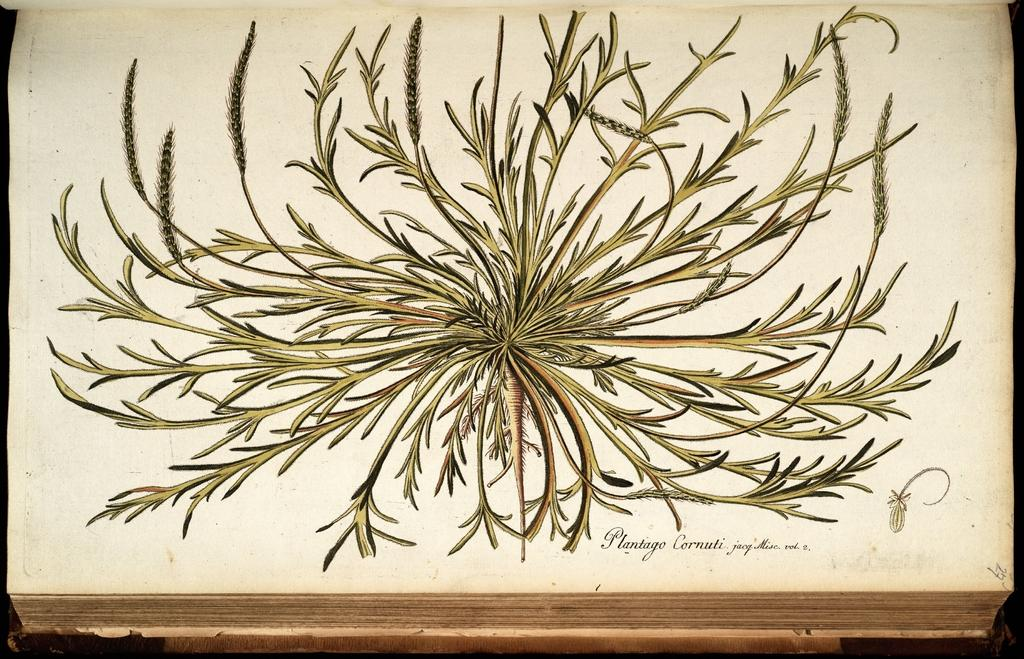What is the main subject of the image? There is a painting in the image. What does the painting depict? The painting depicts a plant. Can you describe the plant in the painting? The plant has seeds and leaves. What is the plant placed on in the painting? The plant is on a white paper. What else is present on the white paper? There is text on the white paper. How would you describe the overall appearance of the image? The background of the image is dark in color. Where is the nest of the bird in the image? There is no nest or bird present in the image; it features a painting of a plant on a white paper with text. How much honey is visible in the image? There is no honey present in the image. 